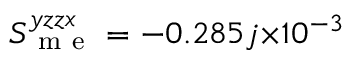Convert formula to latex. <formula><loc_0><loc_0><loc_500><loc_500>S _ { m e } ^ { y z z x } = - 0 . 2 8 5 j { \times } 1 0 ^ { - 3 }</formula> 